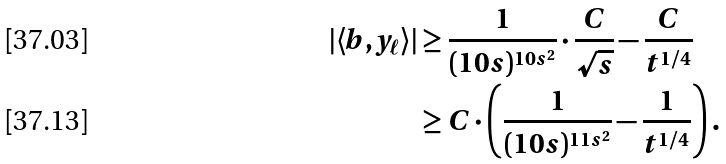<formula> <loc_0><loc_0><loc_500><loc_500>| \langle b , y _ { \ell } \rangle | & \geq \frac { 1 } { ( 1 0 s ) ^ { 1 0 s ^ { 2 } } } \cdot \frac { C } { \sqrt { s } } - \frac { C } { t ^ { 1 / 4 } } \\ & \geq C \cdot \left ( \frac { 1 } { ( 1 0 s ) ^ { 1 1 s ^ { 2 } } } - \frac { 1 } { t ^ { 1 / 4 } } \right ) .</formula> 